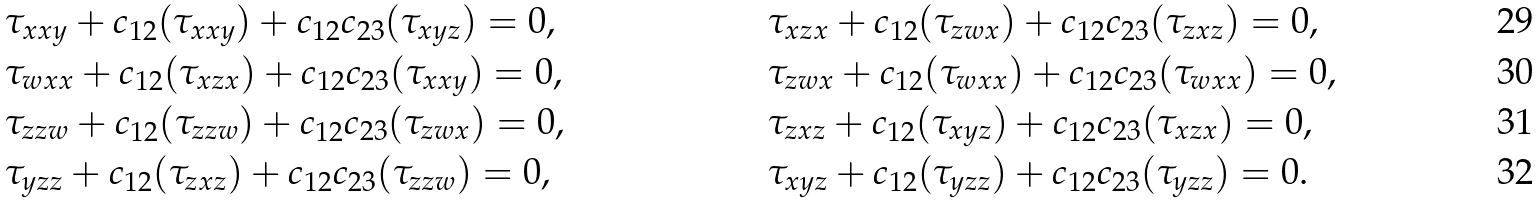<formula> <loc_0><loc_0><loc_500><loc_500>& \tau _ { x x y } + c _ { 1 2 } ( \tau _ { x x y } ) + c _ { 1 2 } c _ { 2 3 } ( \tau _ { x y z } ) = 0 , & \, & \tau _ { x z x } + c _ { 1 2 } ( \tau _ { z w x } ) + c _ { 1 2 } c _ { 2 3 } ( \tau _ { z x z } ) = 0 , \\ & \tau _ { w x x } + c _ { 1 2 } ( \tau _ { x z x } ) + c _ { 1 2 } c _ { 2 3 } ( \tau _ { x x y } ) = 0 , & \, & \tau _ { z w x } + c _ { 1 2 } ( \tau _ { w x x } ) + c _ { 1 2 } c _ { 2 3 } ( \tau _ { w x x } ) = 0 , \\ & \tau _ { z z w } + c _ { 1 2 } ( \tau _ { z z w } ) + c _ { 1 2 } c _ { 2 3 } ( \tau _ { z w x } ) = 0 , & \, & \tau _ { z x z } + c _ { 1 2 } ( \tau _ { x y z } ) + c _ { 1 2 } c _ { 2 3 } ( \tau _ { x z x } ) = 0 , \\ & \tau _ { y z z } + c _ { 1 2 } ( \tau _ { z x z } ) + c _ { 1 2 } c _ { 2 3 } ( \tau _ { z z w } ) = 0 , & \, & \tau _ { x y z } + c _ { 1 2 } ( \tau _ { y z z } ) + c _ { 1 2 } c _ { 2 3 } ( \tau _ { y z z } ) = 0 .</formula> 